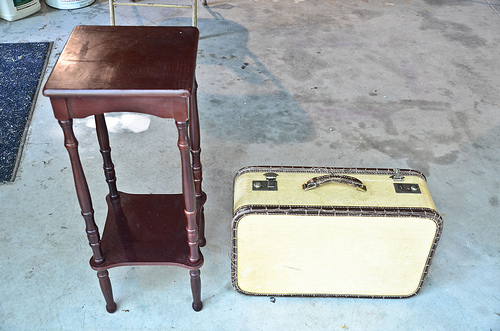<image>
Can you confirm if the stand is in front of the rug? Yes. The stand is positioned in front of the rug, appearing closer to the camera viewpoint. Is there a floor above the suitcase? No. The floor is not positioned above the suitcase. The vertical arrangement shows a different relationship. 